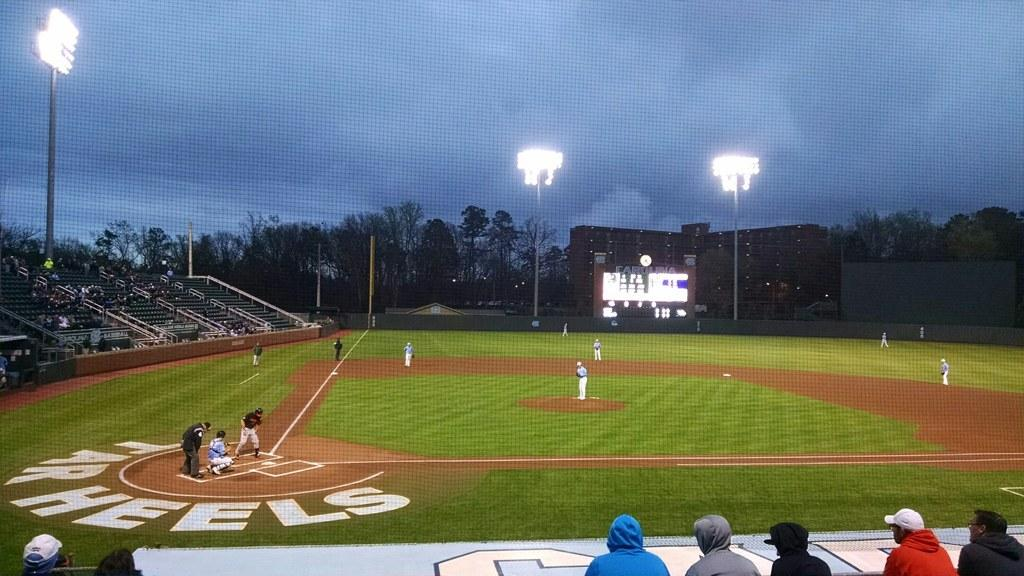<image>
Give a short and clear explanation of the subsequent image. A lit baseball field shows a sign around the home base that reads "TARHEELS." 